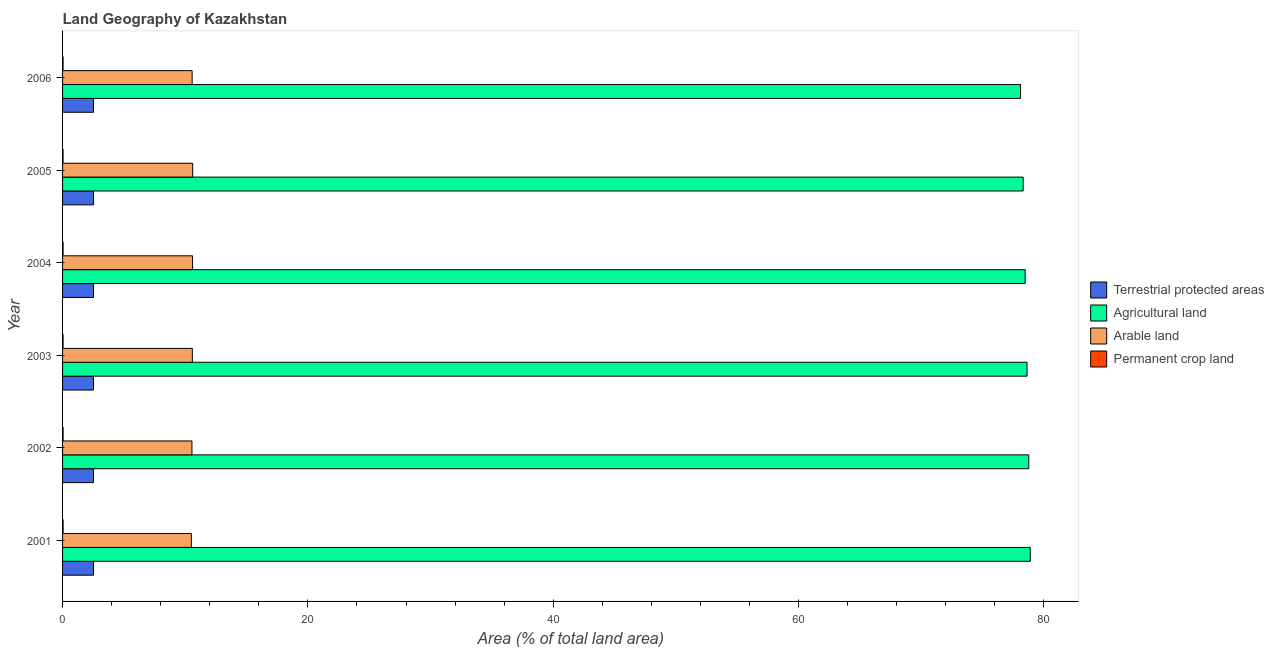How many different coloured bars are there?
Your answer should be very brief. 4. Are the number of bars on each tick of the Y-axis equal?
Your response must be concise. Yes. How many bars are there on the 4th tick from the bottom?
Your response must be concise. 4. In how many cases, is the number of bars for a given year not equal to the number of legend labels?
Your response must be concise. 0. What is the percentage of land under terrestrial protection in 2002?
Make the answer very short. 2.52. Across all years, what is the maximum percentage of land under terrestrial protection?
Your answer should be compact. 2.52. Across all years, what is the minimum percentage of area under arable land?
Your answer should be very brief. 10.5. In which year was the percentage of land under terrestrial protection minimum?
Ensure brevity in your answer.  2001. What is the total percentage of area under permanent crop land in the graph?
Your answer should be very brief. 0.26. What is the difference between the percentage of area under permanent crop land in 2001 and that in 2006?
Your answer should be very brief. 0. What is the difference between the percentage of area under permanent crop land in 2006 and the percentage of area under agricultural land in 2002?
Your response must be concise. -78.73. What is the average percentage of area under permanent crop land per year?
Provide a short and direct response. 0.04. In the year 2001, what is the difference between the percentage of area under agricultural land and percentage of area under arable land?
Ensure brevity in your answer.  68.4. In how many years, is the percentage of area under permanent crop land greater than 52 %?
Ensure brevity in your answer.  0. What is the ratio of the percentage of area under permanent crop land in 2001 to that in 2005?
Make the answer very short. 1.06. Is the percentage of area under arable land in 2002 less than that in 2004?
Provide a short and direct response. Yes. Is the difference between the percentage of land under terrestrial protection in 2005 and 2006 greater than the difference between the percentage of area under agricultural land in 2005 and 2006?
Offer a very short reply. No. What is the difference between the highest and the second highest percentage of area under agricultural land?
Your answer should be compact. 0.12. What is the difference between the highest and the lowest percentage of land under terrestrial protection?
Your answer should be compact. 0. In how many years, is the percentage of area under agricultural land greater than the average percentage of area under agricultural land taken over all years?
Offer a terse response. 3. Is it the case that in every year, the sum of the percentage of land under terrestrial protection and percentage of area under permanent crop land is greater than the sum of percentage of area under agricultural land and percentage of area under arable land?
Make the answer very short. No. What does the 4th bar from the top in 2004 represents?
Your answer should be very brief. Terrestrial protected areas. What does the 2nd bar from the bottom in 2006 represents?
Offer a very short reply. Agricultural land. Is it the case that in every year, the sum of the percentage of land under terrestrial protection and percentage of area under agricultural land is greater than the percentage of area under arable land?
Provide a short and direct response. Yes. How many bars are there?
Ensure brevity in your answer.  24. What is the difference between two consecutive major ticks on the X-axis?
Your answer should be compact. 20. Does the graph contain any zero values?
Your response must be concise. No. Does the graph contain grids?
Make the answer very short. No. How many legend labels are there?
Your answer should be compact. 4. What is the title of the graph?
Provide a succinct answer. Land Geography of Kazakhstan. What is the label or title of the X-axis?
Provide a short and direct response. Area (% of total land area). What is the label or title of the Y-axis?
Make the answer very short. Year. What is the Area (% of total land area) of Terrestrial protected areas in 2001?
Make the answer very short. 2.52. What is the Area (% of total land area) of Agricultural land in 2001?
Your answer should be very brief. 78.9. What is the Area (% of total land area) in Arable land in 2001?
Your answer should be very brief. 10.5. What is the Area (% of total land area) of Permanent crop land in 2001?
Your answer should be compact. 0.05. What is the Area (% of total land area) in Terrestrial protected areas in 2002?
Ensure brevity in your answer.  2.52. What is the Area (% of total land area) in Agricultural land in 2002?
Give a very brief answer. 78.78. What is the Area (% of total land area) of Arable land in 2002?
Offer a very short reply. 10.55. What is the Area (% of total land area) of Permanent crop land in 2002?
Keep it short and to the point. 0.04. What is the Area (% of total land area) of Terrestrial protected areas in 2003?
Give a very brief answer. 2.52. What is the Area (% of total land area) of Agricultural land in 2003?
Offer a terse response. 78.63. What is the Area (% of total land area) in Arable land in 2003?
Offer a terse response. 10.58. What is the Area (% of total land area) of Permanent crop land in 2003?
Your response must be concise. 0.04. What is the Area (% of total land area) of Terrestrial protected areas in 2004?
Offer a terse response. 2.52. What is the Area (% of total land area) of Agricultural land in 2004?
Give a very brief answer. 78.48. What is the Area (% of total land area) in Arable land in 2004?
Offer a terse response. 10.6. What is the Area (% of total land area) of Permanent crop land in 2004?
Offer a terse response. 0.04. What is the Area (% of total land area) of Terrestrial protected areas in 2005?
Ensure brevity in your answer.  2.52. What is the Area (% of total land area) of Agricultural land in 2005?
Provide a short and direct response. 78.32. What is the Area (% of total land area) of Arable land in 2005?
Give a very brief answer. 10.61. What is the Area (% of total land area) in Permanent crop land in 2005?
Your answer should be very brief. 0.04. What is the Area (% of total land area) in Terrestrial protected areas in 2006?
Your answer should be compact. 2.52. What is the Area (% of total land area) of Agricultural land in 2006?
Ensure brevity in your answer.  78.1. What is the Area (% of total land area) in Arable land in 2006?
Keep it short and to the point. 10.56. What is the Area (% of total land area) of Permanent crop land in 2006?
Make the answer very short. 0.04. Across all years, what is the maximum Area (% of total land area) in Terrestrial protected areas?
Your answer should be compact. 2.52. Across all years, what is the maximum Area (% of total land area) of Agricultural land?
Your answer should be very brief. 78.9. Across all years, what is the maximum Area (% of total land area) in Arable land?
Offer a very short reply. 10.61. Across all years, what is the maximum Area (% of total land area) of Permanent crop land?
Make the answer very short. 0.05. Across all years, what is the minimum Area (% of total land area) of Terrestrial protected areas?
Your answer should be very brief. 2.52. Across all years, what is the minimum Area (% of total land area) in Agricultural land?
Provide a short and direct response. 78.1. Across all years, what is the minimum Area (% of total land area) of Arable land?
Keep it short and to the point. 10.5. Across all years, what is the minimum Area (% of total land area) of Permanent crop land?
Provide a succinct answer. 0.04. What is the total Area (% of total land area) of Terrestrial protected areas in the graph?
Give a very brief answer. 15.12. What is the total Area (% of total land area) in Agricultural land in the graph?
Provide a succinct answer. 471.21. What is the total Area (% of total land area) in Arable land in the graph?
Your response must be concise. 63.4. What is the total Area (% of total land area) of Permanent crop land in the graph?
Your response must be concise. 0.26. What is the difference between the Area (% of total land area) of Agricultural land in 2001 and that in 2002?
Provide a short and direct response. 0.12. What is the difference between the Area (% of total land area) in Arable land in 2001 and that in 2002?
Give a very brief answer. -0.05. What is the difference between the Area (% of total land area) in Permanent crop land in 2001 and that in 2002?
Your answer should be compact. 0. What is the difference between the Area (% of total land area) in Terrestrial protected areas in 2001 and that in 2003?
Your answer should be compact. 0. What is the difference between the Area (% of total land area) in Agricultural land in 2001 and that in 2003?
Offer a terse response. 0.27. What is the difference between the Area (% of total land area) in Arable land in 2001 and that in 2003?
Your answer should be very brief. -0.08. What is the difference between the Area (% of total land area) in Permanent crop land in 2001 and that in 2003?
Your answer should be compact. 0. What is the difference between the Area (% of total land area) of Terrestrial protected areas in 2001 and that in 2004?
Offer a terse response. 0. What is the difference between the Area (% of total land area) in Agricultural land in 2001 and that in 2004?
Offer a terse response. 0.42. What is the difference between the Area (% of total land area) in Arable land in 2001 and that in 2004?
Ensure brevity in your answer.  -0.1. What is the difference between the Area (% of total land area) of Permanent crop land in 2001 and that in 2004?
Provide a succinct answer. 0. What is the difference between the Area (% of total land area) in Agricultural land in 2001 and that in 2005?
Your response must be concise. 0.58. What is the difference between the Area (% of total land area) in Arable land in 2001 and that in 2005?
Your answer should be very brief. -0.11. What is the difference between the Area (% of total land area) in Permanent crop land in 2001 and that in 2005?
Your answer should be compact. 0. What is the difference between the Area (% of total land area) in Terrestrial protected areas in 2001 and that in 2006?
Offer a very short reply. 0. What is the difference between the Area (% of total land area) in Agricultural land in 2001 and that in 2006?
Offer a terse response. 0.8. What is the difference between the Area (% of total land area) in Arable land in 2001 and that in 2006?
Offer a very short reply. -0.07. What is the difference between the Area (% of total land area) of Permanent crop land in 2001 and that in 2006?
Offer a very short reply. 0. What is the difference between the Area (% of total land area) in Agricultural land in 2002 and that in 2003?
Keep it short and to the point. 0.14. What is the difference between the Area (% of total land area) in Arable land in 2002 and that in 2003?
Offer a terse response. -0.03. What is the difference between the Area (% of total land area) of Permanent crop land in 2002 and that in 2003?
Offer a very short reply. 0. What is the difference between the Area (% of total land area) in Terrestrial protected areas in 2002 and that in 2004?
Offer a terse response. 0. What is the difference between the Area (% of total land area) in Agricultural land in 2002 and that in 2004?
Make the answer very short. 0.29. What is the difference between the Area (% of total land area) in Arable land in 2002 and that in 2004?
Keep it short and to the point. -0.05. What is the difference between the Area (% of total land area) of Permanent crop land in 2002 and that in 2004?
Your answer should be compact. 0. What is the difference between the Area (% of total land area) of Agricultural land in 2002 and that in 2005?
Make the answer very short. 0.46. What is the difference between the Area (% of total land area) in Arable land in 2002 and that in 2005?
Your answer should be very brief. -0.06. What is the difference between the Area (% of total land area) of Permanent crop land in 2002 and that in 2005?
Offer a very short reply. 0. What is the difference between the Area (% of total land area) in Agricultural land in 2002 and that in 2006?
Give a very brief answer. 0.67. What is the difference between the Area (% of total land area) of Arable land in 2002 and that in 2006?
Provide a succinct answer. -0.02. What is the difference between the Area (% of total land area) of Permanent crop land in 2002 and that in 2006?
Your response must be concise. 0. What is the difference between the Area (% of total land area) of Agricultural land in 2003 and that in 2004?
Offer a very short reply. 0.15. What is the difference between the Area (% of total land area) in Arable land in 2003 and that in 2004?
Keep it short and to the point. -0.02. What is the difference between the Area (% of total land area) of Terrestrial protected areas in 2003 and that in 2005?
Ensure brevity in your answer.  0. What is the difference between the Area (% of total land area) of Agricultural land in 2003 and that in 2005?
Provide a succinct answer. 0.32. What is the difference between the Area (% of total land area) in Arable land in 2003 and that in 2005?
Make the answer very short. -0.03. What is the difference between the Area (% of total land area) in Agricultural land in 2003 and that in 2006?
Provide a succinct answer. 0.53. What is the difference between the Area (% of total land area) of Arable land in 2003 and that in 2006?
Offer a terse response. 0.02. What is the difference between the Area (% of total land area) in Terrestrial protected areas in 2004 and that in 2005?
Your answer should be very brief. 0. What is the difference between the Area (% of total land area) in Agricultural land in 2004 and that in 2005?
Provide a succinct answer. 0.16. What is the difference between the Area (% of total land area) of Arable land in 2004 and that in 2005?
Your response must be concise. -0.01. What is the difference between the Area (% of total land area) in Permanent crop land in 2004 and that in 2005?
Your answer should be compact. 0. What is the difference between the Area (% of total land area) in Terrestrial protected areas in 2004 and that in 2006?
Give a very brief answer. 0. What is the difference between the Area (% of total land area) of Agricultural land in 2004 and that in 2006?
Keep it short and to the point. 0.38. What is the difference between the Area (% of total land area) in Arable land in 2004 and that in 2006?
Provide a succinct answer. 0.04. What is the difference between the Area (% of total land area) in Permanent crop land in 2004 and that in 2006?
Offer a very short reply. 0. What is the difference between the Area (% of total land area) of Agricultural land in 2005 and that in 2006?
Offer a terse response. 0.22. What is the difference between the Area (% of total land area) in Arable land in 2005 and that in 2006?
Your answer should be compact. 0.04. What is the difference between the Area (% of total land area) in Permanent crop land in 2005 and that in 2006?
Make the answer very short. -0. What is the difference between the Area (% of total land area) in Terrestrial protected areas in 2001 and the Area (% of total land area) in Agricultural land in 2002?
Give a very brief answer. -76.25. What is the difference between the Area (% of total land area) of Terrestrial protected areas in 2001 and the Area (% of total land area) of Arable land in 2002?
Ensure brevity in your answer.  -8.03. What is the difference between the Area (% of total land area) of Terrestrial protected areas in 2001 and the Area (% of total land area) of Permanent crop land in 2002?
Offer a terse response. 2.48. What is the difference between the Area (% of total land area) of Agricultural land in 2001 and the Area (% of total land area) of Arable land in 2002?
Your response must be concise. 68.35. What is the difference between the Area (% of total land area) of Agricultural land in 2001 and the Area (% of total land area) of Permanent crop land in 2002?
Make the answer very short. 78.85. What is the difference between the Area (% of total land area) of Arable land in 2001 and the Area (% of total land area) of Permanent crop land in 2002?
Provide a short and direct response. 10.45. What is the difference between the Area (% of total land area) of Terrestrial protected areas in 2001 and the Area (% of total land area) of Agricultural land in 2003?
Your answer should be compact. -76.11. What is the difference between the Area (% of total land area) of Terrestrial protected areas in 2001 and the Area (% of total land area) of Arable land in 2003?
Keep it short and to the point. -8.06. What is the difference between the Area (% of total land area) of Terrestrial protected areas in 2001 and the Area (% of total land area) of Permanent crop land in 2003?
Your answer should be very brief. 2.48. What is the difference between the Area (% of total land area) of Agricultural land in 2001 and the Area (% of total land area) of Arable land in 2003?
Provide a short and direct response. 68.32. What is the difference between the Area (% of total land area) in Agricultural land in 2001 and the Area (% of total land area) in Permanent crop land in 2003?
Ensure brevity in your answer.  78.86. What is the difference between the Area (% of total land area) in Arable land in 2001 and the Area (% of total land area) in Permanent crop land in 2003?
Ensure brevity in your answer.  10.46. What is the difference between the Area (% of total land area) of Terrestrial protected areas in 2001 and the Area (% of total land area) of Agricultural land in 2004?
Give a very brief answer. -75.96. What is the difference between the Area (% of total land area) in Terrestrial protected areas in 2001 and the Area (% of total land area) in Arable land in 2004?
Offer a terse response. -8.08. What is the difference between the Area (% of total land area) in Terrestrial protected areas in 2001 and the Area (% of total land area) in Permanent crop land in 2004?
Provide a succinct answer. 2.48. What is the difference between the Area (% of total land area) of Agricultural land in 2001 and the Area (% of total land area) of Arable land in 2004?
Your answer should be compact. 68.3. What is the difference between the Area (% of total land area) of Agricultural land in 2001 and the Area (% of total land area) of Permanent crop land in 2004?
Offer a terse response. 78.86. What is the difference between the Area (% of total land area) in Arable land in 2001 and the Area (% of total land area) in Permanent crop land in 2004?
Ensure brevity in your answer.  10.46. What is the difference between the Area (% of total land area) in Terrestrial protected areas in 2001 and the Area (% of total land area) in Agricultural land in 2005?
Offer a terse response. -75.8. What is the difference between the Area (% of total land area) in Terrestrial protected areas in 2001 and the Area (% of total land area) in Arable land in 2005?
Ensure brevity in your answer.  -8.09. What is the difference between the Area (% of total land area) in Terrestrial protected areas in 2001 and the Area (% of total land area) in Permanent crop land in 2005?
Your answer should be very brief. 2.48. What is the difference between the Area (% of total land area) in Agricultural land in 2001 and the Area (% of total land area) in Arable land in 2005?
Offer a very short reply. 68.29. What is the difference between the Area (% of total land area) in Agricultural land in 2001 and the Area (% of total land area) in Permanent crop land in 2005?
Your response must be concise. 78.86. What is the difference between the Area (% of total land area) in Arable land in 2001 and the Area (% of total land area) in Permanent crop land in 2005?
Offer a very short reply. 10.46. What is the difference between the Area (% of total land area) in Terrestrial protected areas in 2001 and the Area (% of total land area) in Agricultural land in 2006?
Your answer should be very brief. -75.58. What is the difference between the Area (% of total land area) of Terrestrial protected areas in 2001 and the Area (% of total land area) of Arable land in 2006?
Provide a short and direct response. -8.04. What is the difference between the Area (% of total land area) in Terrestrial protected areas in 2001 and the Area (% of total land area) in Permanent crop land in 2006?
Provide a short and direct response. 2.48. What is the difference between the Area (% of total land area) of Agricultural land in 2001 and the Area (% of total land area) of Arable land in 2006?
Provide a succinct answer. 68.33. What is the difference between the Area (% of total land area) of Agricultural land in 2001 and the Area (% of total land area) of Permanent crop land in 2006?
Offer a very short reply. 78.86. What is the difference between the Area (% of total land area) of Arable land in 2001 and the Area (% of total land area) of Permanent crop land in 2006?
Offer a terse response. 10.46. What is the difference between the Area (% of total land area) in Terrestrial protected areas in 2002 and the Area (% of total land area) in Agricultural land in 2003?
Your answer should be compact. -76.11. What is the difference between the Area (% of total land area) of Terrestrial protected areas in 2002 and the Area (% of total land area) of Arable land in 2003?
Provide a short and direct response. -8.06. What is the difference between the Area (% of total land area) in Terrestrial protected areas in 2002 and the Area (% of total land area) in Permanent crop land in 2003?
Give a very brief answer. 2.48. What is the difference between the Area (% of total land area) in Agricultural land in 2002 and the Area (% of total land area) in Arable land in 2003?
Your response must be concise. 68.2. What is the difference between the Area (% of total land area) of Agricultural land in 2002 and the Area (% of total land area) of Permanent crop land in 2003?
Your answer should be compact. 78.73. What is the difference between the Area (% of total land area) of Arable land in 2002 and the Area (% of total land area) of Permanent crop land in 2003?
Your response must be concise. 10.51. What is the difference between the Area (% of total land area) of Terrestrial protected areas in 2002 and the Area (% of total land area) of Agricultural land in 2004?
Ensure brevity in your answer.  -75.96. What is the difference between the Area (% of total land area) in Terrestrial protected areas in 2002 and the Area (% of total land area) in Arable land in 2004?
Provide a succinct answer. -8.08. What is the difference between the Area (% of total land area) of Terrestrial protected areas in 2002 and the Area (% of total land area) of Permanent crop land in 2004?
Your answer should be compact. 2.48. What is the difference between the Area (% of total land area) of Agricultural land in 2002 and the Area (% of total land area) of Arable land in 2004?
Give a very brief answer. 68.18. What is the difference between the Area (% of total land area) of Agricultural land in 2002 and the Area (% of total land area) of Permanent crop land in 2004?
Ensure brevity in your answer.  78.73. What is the difference between the Area (% of total land area) of Arable land in 2002 and the Area (% of total land area) of Permanent crop land in 2004?
Ensure brevity in your answer.  10.51. What is the difference between the Area (% of total land area) of Terrestrial protected areas in 2002 and the Area (% of total land area) of Agricultural land in 2005?
Provide a succinct answer. -75.8. What is the difference between the Area (% of total land area) of Terrestrial protected areas in 2002 and the Area (% of total land area) of Arable land in 2005?
Provide a short and direct response. -8.09. What is the difference between the Area (% of total land area) in Terrestrial protected areas in 2002 and the Area (% of total land area) in Permanent crop land in 2005?
Give a very brief answer. 2.48. What is the difference between the Area (% of total land area) in Agricultural land in 2002 and the Area (% of total land area) in Arable land in 2005?
Your response must be concise. 68.17. What is the difference between the Area (% of total land area) in Agricultural land in 2002 and the Area (% of total land area) in Permanent crop land in 2005?
Provide a succinct answer. 78.73. What is the difference between the Area (% of total land area) of Arable land in 2002 and the Area (% of total land area) of Permanent crop land in 2005?
Your answer should be compact. 10.51. What is the difference between the Area (% of total land area) in Terrestrial protected areas in 2002 and the Area (% of total land area) in Agricultural land in 2006?
Your answer should be very brief. -75.58. What is the difference between the Area (% of total land area) in Terrestrial protected areas in 2002 and the Area (% of total land area) in Arable land in 2006?
Ensure brevity in your answer.  -8.04. What is the difference between the Area (% of total land area) of Terrestrial protected areas in 2002 and the Area (% of total land area) of Permanent crop land in 2006?
Provide a succinct answer. 2.48. What is the difference between the Area (% of total land area) in Agricultural land in 2002 and the Area (% of total land area) in Arable land in 2006?
Offer a terse response. 68.21. What is the difference between the Area (% of total land area) in Agricultural land in 2002 and the Area (% of total land area) in Permanent crop land in 2006?
Ensure brevity in your answer.  78.73. What is the difference between the Area (% of total land area) in Arable land in 2002 and the Area (% of total land area) in Permanent crop land in 2006?
Your answer should be compact. 10.51. What is the difference between the Area (% of total land area) in Terrestrial protected areas in 2003 and the Area (% of total land area) in Agricultural land in 2004?
Provide a short and direct response. -75.96. What is the difference between the Area (% of total land area) in Terrestrial protected areas in 2003 and the Area (% of total land area) in Arable land in 2004?
Offer a terse response. -8.08. What is the difference between the Area (% of total land area) in Terrestrial protected areas in 2003 and the Area (% of total land area) in Permanent crop land in 2004?
Ensure brevity in your answer.  2.48. What is the difference between the Area (% of total land area) of Agricultural land in 2003 and the Area (% of total land area) of Arable land in 2004?
Make the answer very short. 68.03. What is the difference between the Area (% of total land area) in Agricultural land in 2003 and the Area (% of total land area) in Permanent crop land in 2004?
Keep it short and to the point. 78.59. What is the difference between the Area (% of total land area) in Arable land in 2003 and the Area (% of total land area) in Permanent crop land in 2004?
Your answer should be very brief. 10.54. What is the difference between the Area (% of total land area) in Terrestrial protected areas in 2003 and the Area (% of total land area) in Agricultural land in 2005?
Keep it short and to the point. -75.8. What is the difference between the Area (% of total land area) in Terrestrial protected areas in 2003 and the Area (% of total land area) in Arable land in 2005?
Offer a terse response. -8.09. What is the difference between the Area (% of total land area) of Terrestrial protected areas in 2003 and the Area (% of total land area) of Permanent crop land in 2005?
Offer a terse response. 2.48. What is the difference between the Area (% of total land area) of Agricultural land in 2003 and the Area (% of total land area) of Arable land in 2005?
Keep it short and to the point. 68.02. What is the difference between the Area (% of total land area) of Agricultural land in 2003 and the Area (% of total land area) of Permanent crop land in 2005?
Provide a short and direct response. 78.59. What is the difference between the Area (% of total land area) of Arable land in 2003 and the Area (% of total land area) of Permanent crop land in 2005?
Ensure brevity in your answer.  10.54. What is the difference between the Area (% of total land area) in Terrestrial protected areas in 2003 and the Area (% of total land area) in Agricultural land in 2006?
Offer a very short reply. -75.58. What is the difference between the Area (% of total land area) of Terrestrial protected areas in 2003 and the Area (% of total land area) of Arable land in 2006?
Offer a very short reply. -8.04. What is the difference between the Area (% of total land area) in Terrestrial protected areas in 2003 and the Area (% of total land area) in Permanent crop land in 2006?
Make the answer very short. 2.48. What is the difference between the Area (% of total land area) in Agricultural land in 2003 and the Area (% of total land area) in Arable land in 2006?
Ensure brevity in your answer.  68.07. What is the difference between the Area (% of total land area) of Agricultural land in 2003 and the Area (% of total land area) of Permanent crop land in 2006?
Offer a very short reply. 78.59. What is the difference between the Area (% of total land area) of Arable land in 2003 and the Area (% of total land area) of Permanent crop land in 2006?
Offer a terse response. 10.54. What is the difference between the Area (% of total land area) in Terrestrial protected areas in 2004 and the Area (% of total land area) in Agricultural land in 2005?
Make the answer very short. -75.8. What is the difference between the Area (% of total land area) of Terrestrial protected areas in 2004 and the Area (% of total land area) of Arable land in 2005?
Your answer should be very brief. -8.09. What is the difference between the Area (% of total land area) of Terrestrial protected areas in 2004 and the Area (% of total land area) of Permanent crop land in 2005?
Make the answer very short. 2.48. What is the difference between the Area (% of total land area) in Agricultural land in 2004 and the Area (% of total land area) in Arable land in 2005?
Your answer should be very brief. 67.87. What is the difference between the Area (% of total land area) of Agricultural land in 2004 and the Area (% of total land area) of Permanent crop land in 2005?
Ensure brevity in your answer.  78.44. What is the difference between the Area (% of total land area) in Arable land in 2004 and the Area (% of total land area) in Permanent crop land in 2005?
Offer a terse response. 10.56. What is the difference between the Area (% of total land area) in Terrestrial protected areas in 2004 and the Area (% of total land area) in Agricultural land in 2006?
Make the answer very short. -75.58. What is the difference between the Area (% of total land area) in Terrestrial protected areas in 2004 and the Area (% of total land area) in Arable land in 2006?
Offer a terse response. -8.04. What is the difference between the Area (% of total land area) in Terrestrial protected areas in 2004 and the Area (% of total land area) in Permanent crop land in 2006?
Offer a terse response. 2.48. What is the difference between the Area (% of total land area) in Agricultural land in 2004 and the Area (% of total land area) in Arable land in 2006?
Your answer should be very brief. 67.92. What is the difference between the Area (% of total land area) in Agricultural land in 2004 and the Area (% of total land area) in Permanent crop land in 2006?
Offer a very short reply. 78.44. What is the difference between the Area (% of total land area) in Arable land in 2004 and the Area (% of total land area) in Permanent crop land in 2006?
Your response must be concise. 10.56. What is the difference between the Area (% of total land area) of Terrestrial protected areas in 2005 and the Area (% of total land area) of Agricultural land in 2006?
Offer a very short reply. -75.58. What is the difference between the Area (% of total land area) in Terrestrial protected areas in 2005 and the Area (% of total land area) in Arable land in 2006?
Give a very brief answer. -8.04. What is the difference between the Area (% of total land area) of Terrestrial protected areas in 2005 and the Area (% of total land area) of Permanent crop land in 2006?
Offer a terse response. 2.48. What is the difference between the Area (% of total land area) of Agricultural land in 2005 and the Area (% of total land area) of Arable land in 2006?
Provide a succinct answer. 67.75. What is the difference between the Area (% of total land area) in Agricultural land in 2005 and the Area (% of total land area) in Permanent crop land in 2006?
Give a very brief answer. 78.28. What is the difference between the Area (% of total land area) in Arable land in 2005 and the Area (% of total land area) in Permanent crop land in 2006?
Give a very brief answer. 10.57. What is the average Area (% of total land area) in Terrestrial protected areas per year?
Ensure brevity in your answer.  2.52. What is the average Area (% of total land area) of Agricultural land per year?
Provide a short and direct response. 78.53. What is the average Area (% of total land area) of Arable land per year?
Give a very brief answer. 10.57. What is the average Area (% of total land area) of Permanent crop land per year?
Provide a succinct answer. 0.04. In the year 2001, what is the difference between the Area (% of total land area) of Terrestrial protected areas and Area (% of total land area) of Agricultural land?
Provide a succinct answer. -76.38. In the year 2001, what is the difference between the Area (% of total land area) in Terrestrial protected areas and Area (% of total land area) in Arable land?
Make the answer very short. -7.98. In the year 2001, what is the difference between the Area (% of total land area) in Terrestrial protected areas and Area (% of total land area) in Permanent crop land?
Offer a very short reply. 2.48. In the year 2001, what is the difference between the Area (% of total land area) of Agricultural land and Area (% of total land area) of Arable land?
Your answer should be very brief. 68.4. In the year 2001, what is the difference between the Area (% of total land area) in Agricultural land and Area (% of total land area) in Permanent crop land?
Offer a terse response. 78.85. In the year 2001, what is the difference between the Area (% of total land area) in Arable land and Area (% of total land area) in Permanent crop land?
Your answer should be compact. 10.45. In the year 2002, what is the difference between the Area (% of total land area) of Terrestrial protected areas and Area (% of total land area) of Agricultural land?
Provide a short and direct response. -76.25. In the year 2002, what is the difference between the Area (% of total land area) in Terrestrial protected areas and Area (% of total land area) in Arable land?
Your answer should be compact. -8.03. In the year 2002, what is the difference between the Area (% of total land area) of Terrestrial protected areas and Area (% of total land area) of Permanent crop land?
Provide a succinct answer. 2.48. In the year 2002, what is the difference between the Area (% of total land area) of Agricultural land and Area (% of total land area) of Arable land?
Your answer should be compact. 68.23. In the year 2002, what is the difference between the Area (% of total land area) in Agricultural land and Area (% of total land area) in Permanent crop land?
Offer a terse response. 78.73. In the year 2002, what is the difference between the Area (% of total land area) in Arable land and Area (% of total land area) in Permanent crop land?
Your response must be concise. 10.5. In the year 2003, what is the difference between the Area (% of total land area) of Terrestrial protected areas and Area (% of total land area) of Agricultural land?
Your answer should be very brief. -76.11. In the year 2003, what is the difference between the Area (% of total land area) in Terrestrial protected areas and Area (% of total land area) in Arable land?
Make the answer very short. -8.06. In the year 2003, what is the difference between the Area (% of total land area) in Terrestrial protected areas and Area (% of total land area) in Permanent crop land?
Keep it short and to the point. 2.48. In the year 2003, what is the difference between the Area (% of total land area) in Agricultural land and Area (% of total land area) in Arable land?
Make the answer very short. 68.05. In the year 2003, what is the difference between the Area (% of total land area) in Agricultural land and Area (% of total land area) in Permanent crop land?
Ensure brevity in your answer.  78.59. In the year 2003, what is the difference between the Area (% of total land area) of Arable land and Area (% of total land area) of Permanent crop land?
Provide a short and direct response. 10.54. In the year 2004, what is the difference between the Area (% of total land area) in Terrestrial protected areas and Area (% of total land area) in Agricultural land?
Provide a succinct answer. -75.96. In the year 2004, what is the difference between the Area (% of total land area) in Terrestrial protected areas and Area (% of total land area) in Arable land?
Your answer should be very brief. -8.08. In the year 2004, what is the difference between the Area (% of total land area) of Terrestrial protected areas and Area (% of total land area) of Permanent crop land?
Provide a short and direct response. 2.48. In the year 2004, what is the difference between the Area (% of total land area) in Agricultural land and Area (% of total land area) in Arable land?
Provide a succinct answer. 67.88. In the year 2004, what is the difference between the Area (% of total land area) in Agricultural land and Area (% of total land area) in Permanent crop land?
Keep it short and to the point. 78.44. In the year 2004, what is the difference between the Area (% of total land area) in Arable land and Area (% of total land area) in Permanent crop land?
Make the answer very short. 10.56. In the year 2005, what is the difference between the Area (% of total land area) of Terrestrial protected areas and Area (% of total land area) of Agricultural land?
Make the answer very short. -75.8. In the year 2005, what is the difference between the Area (% of total land area) in Terrestrial protected areas and Area (% of total land area) in Arable land?
Give a very brief answer. -8.09. In the year 2005, what is the difference between the Area (% of total land area) of Terrestrial protected areas and Area (% of total land area) of Permanent crop land?
Your response must be concise. 2.48. In the year 2005, what is the difference between the Area (% of total land area) in Agricultural land and Area (% of total land area) in Arable land?
Make the answer very short. 67.71. In the year 2005, what is the difference between the Area (% of total land area) in Agricultural land and Area (% of total land area) in Permanent crop land?
Ensure brevity in your answer.  78.28. In the year 2005, what is the difference between the Area (% of total land area) in Arable land and Area (% of total land area) in Permanent crop land?
Your answer should be compact. 10.57. In the year 2006, what is the difference between the Area (% of total land area) of Terrestrial protected areas and Area (% of total land area) of Agricultural land?
Your response must be concise. -75.58. In the year 2006, what is the difference between the Area (% of total land area) in Terrestrial protected areas and Area (% of total land area) in Arable land?
Your response must be concise. -8.04. In the year 2006, what is the difference between the Area (% of total land area) of Terrestrial protected areas and Area (% of total land area) of Permanent crop land?
Provide a short and direct response. 2.48. In the year 2006, what is the difference between the Area (% of total land area) of Agricultural land and Area (% of total land area) of Arable land?
Ensure brevity in your answer.  67.54. In the year 2006, what is the difference between the Area (% of total land area) of Agricultural land and Area (% of total land area) of Permanent crop land?
Make the answer very short. 78.06. In the year 2006, what is the difference between the Area (% of total land area) in Arable land and Area (% of total land area) in Permanent crop land?
Provide a short and direct response. 10.52. What is the ratio of the Area (% of total land area) in Terrestrial protected areas in 2001 to that in 2002?
Keep it short and to the point. 1. What is the ratio of the Area (% of total land area) in Agricultural land in 2001 to that in 2002?
Your answer should be compact. 1. What is the ratio of the Area (% of total land area) of Arable land in 2001 to that in 2002?
Provide a short and direct response. 1. What is the ratio of the Area (% of total land area) in Permanent crop land in 2001 to that in 2002?
Keep it short and to the point. 1.02. What is the ratio of the Area (% of total land area) of Terrestrial protected areas in 2001 to that in 2003?
Provide a succinct answer. 1. What is the ratio of the Area (% of total land area) of Agricultural land in 2001 to that in 2003?
Give a very brief answer. 1. What is the ratio of the Area (% of total land area) in Arable land in 2001 to that in 2003?
Provide a succinct answer. 0.99. What is the ratio of the Area (% of total land area) in Permanent crop land in 2001 to that in 2003?
Keep it short and to the point. 1.05. What is the ratio of the Area (% of total land area) of Agricultural land in 2001 to that in 2004?
Your answer should be very brief. 1.01. What is the ratio of the Area (% of total land area) in Permanent crop land in 2001 to that in 2004?
Provide a succinct answer. 1.05. What is the ratio of the Area (% of total land area) in Agricultural land in 2001 to that in 2005?
Provide a succinct answer. 1.01. What is the ratio of the Area (% of total land area) of Arable land in 2001 to that in 2005?
Keep it short and to the point. 0.99. What is the ratio of the Area (% of total land area) in Permanent crop land in 2001 to that in 2005?
Ensure brevity in your answer.  1.06. What is the ratio of the Area (% of total land area) in Terrestrial protected areas in 2001 to that in 2006?
Provide a succinct answer. 1. What is the ratio of the Area (% of total land area) of Agricultural land in 2001 to that in 2006?
Offer a very short reply. 1.01. What is the ratio of the Area (% of total land area) in Arable land in 2001 to that in 2006?
Offer a terse response. 0.99. What is the ratio of the Area (% of total land area) in Permanent crop land in 2001 to that in 2006?
Ensure brevity in your answer.  1.06. What is the ratio of the Area (% of total land area) of Terrestrial protected areas in 2002 to that in 2003?
Provide a succinct answer. 1. What is the ratio of the Area (% of total land area) of Agricultural land in 2002 to that in 2003?
Make the answer very short. 1. What is the ratio of the Area (% of total land area) in Arable land in 2002 to that in 2003?
Your response must be concise. 1. What is the ratio of the Area (% of total land area) in Permanent crop land in 2002 to that in 2003?
Provide a succinct answer. 1.03. What is the ratio of the Area (% of total land area) in Terrestrial protected areas in 2002 to that in 2004?
Your answer should be compact. 1. What is the ratio of the Area (% of total land area) in Agricultural land in 2002 to that in 2004?
Your response must be concise. 1. What is the ratio of the Area (% of total land area) in Arable land in 2002 to that in 2004?
Give a very brief answer. 1. What is the ratio of the Area (% of total land area) of Permanent crop land in 2002 to that in 2004?
Make the answer very short. 1.04. What is the ratio of the Area (% of total land area) in Terrestrial protected areas in 2002 to that in 2005?
Your answer should be compact. 1. What is the ratio of the Area (% of total land area) of Agricultural land in 2002 to that in 2005?
Your response must be concise. 1.01. What is the ratio of the Area (% of total land area) in Permanent crop land in 2002 to that in 2005?
Your response must be concise. 1.05. What is the ratio of the Area (% of total land area) in Terrestrial protected areas in 2002 to that in 2006?
Offer a terse response. 1. What is the ratio of the Area (% of total land area) in Agricultural land in 2002 to that in 2006?
Offer a very short reply. 1.01. What is the ratio of the Area (% of total land area) in Arable land in 2002 to that in 2006?
Ensure brevity in your answer.  1. What is the ratio of the Area (% of total land area) in Permanent crop land in 2002 to that in 2006?
Give a very brief answer. 1.04. What is the ratio of the Area (% of total land area) of Agricultural land in 2003 to that in 2004?
Ensure brevity in your answer.  1. What is the ratio of the Area (% of total land area) in Agricultural land in 2003 to that in 2005?
Provide a short and direct response. 1. What is the ratio of the Area (% of total land area) of Arable land in 2003 to that in 2005?
Provide a short and direct response. 1. What is the ratio of the Area (% of total land area) in Permanent crop land in 2003 to that in 2005?
Ensure brevity in your answer.  1.01. What is the ratio of the Area (% of total land area) of Agricultural land in 2003 to that in 2006?
Keep it short and to the point. 1.01. What is the ratio of the Area (% of total land area) of Arable land in 2003 to that in 2006?
Offer a terse response. 1. What is the ratio of the Area (% of total land area) in Arable land in 2004 to that in 2005?
Keep it short and to the point. 1. What is the ratio of the Area (% of total land area) of Permanent crop land in 2004 to that in 2005?
Provide a succinct answer. 1.01. What is the ratio of the Area (% of total land area) of Agricultural land in 2004 to that in 2006?
Make the answer very short. 1. What is the ratio of the Area (% of total land area) of Arable land in 2004 to that in 2006?
Make the answer very short. 1. What is the ratio of the Area (% of total land area) in Arable land in 2005 to that in 2006?
Provide a short and direct response. 1. What is the difference between the highest and the second highest Area (% of total land area) in Agricultural land?
Give a very brief answer. 0.12. What is the difference between the highest and the second highest Area (% of total land area) of Arable land?
Your answer should be compact. 0.01. What is the difference between the highest and the second highest Area (% of total land area) of Permanent crop land?
Your response must be concise. 0. What is the difference between the highest and the lowest Area (% of total land area) of Agricultural land?
Provide a short and direct response. 0.8. What is the difference between the highest and the lowest Area (% of total land area) of Arable land?
Your response must be concise. 0.11. What is the difference between the highest and the lowest Area (% of total land area) of Permanent crop land?
Provide a short and direct response. 0. 